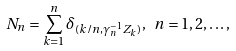Convert formula to latex. <formula><loc_0><loc_0><loc_500><loc_500>N _ { n } = \sum _ { k = 1 } ^ { n } \delta _ { ( k / n , \gamma _ { n } ^ { - 1 } Z _ { k } ) } , \ n = 1 , 2 , \dots ,</formula> 